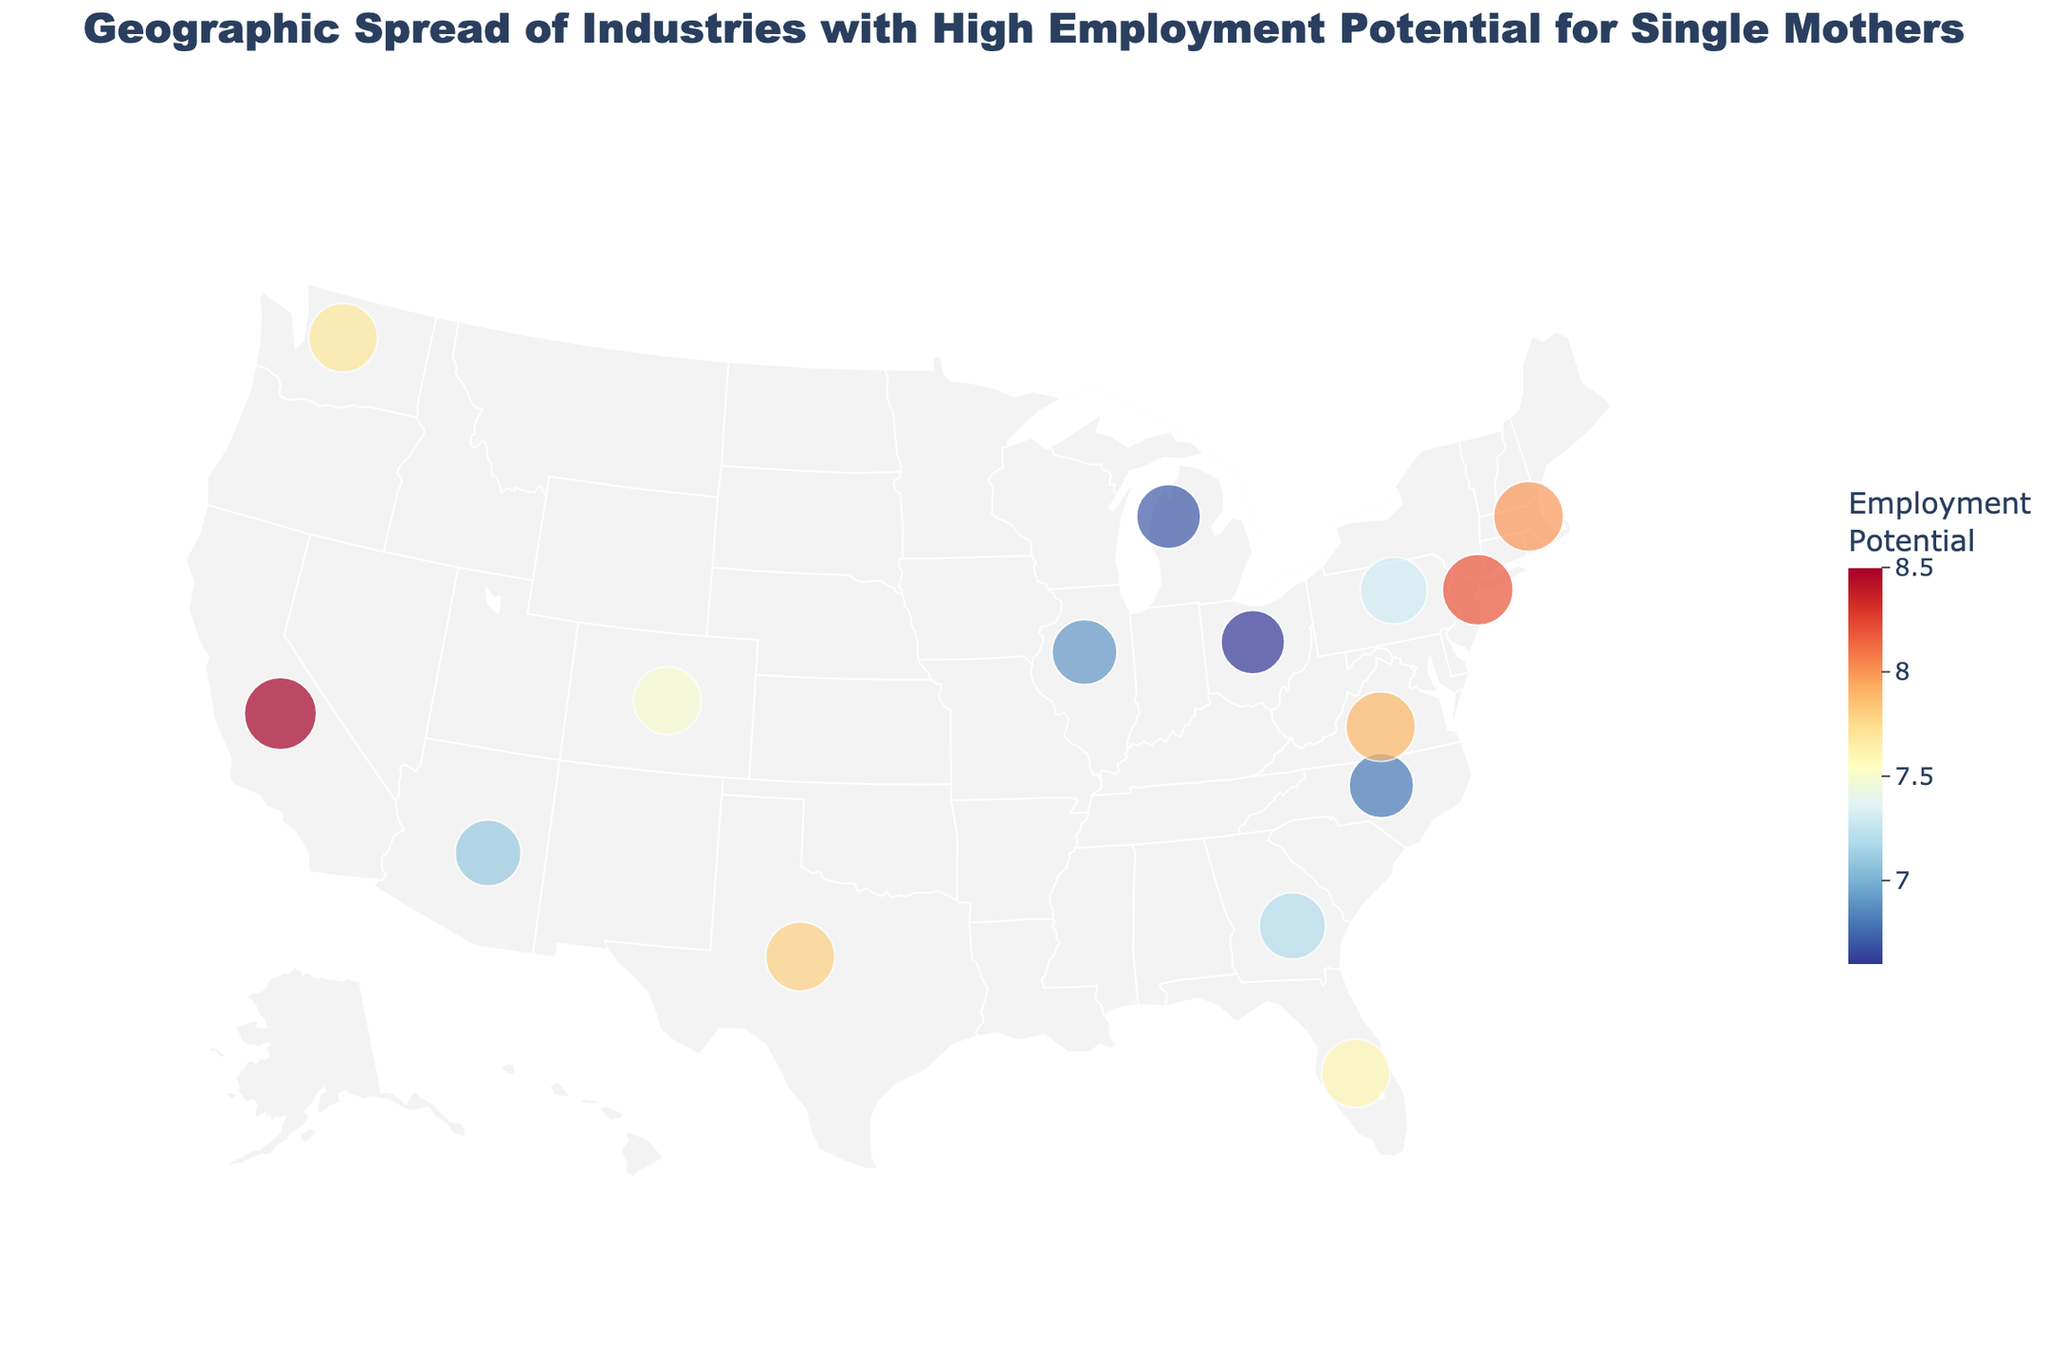What is the title of the figure? The title of the figure is typically located at the top and is often formatted in a larger font size. Here, it should be descriptive of the content, which is the Geographic Spread of Industries with High Employment Potential for Single Mothers.
Answer: Geographic Spread of Industries with High Employment Potential for Single Mothers Which state has the highest employment potential for single mothers? Look for the state with the highest number in the "Employment Potential" category on the map. The size of the marker and the color intensity can also indicate higher employment potential.
Answer: California What industry is represented in Florida? Hover over or find the text label near Florida on the map to identify the industry.
Answer: Hospitality How many states have an employment potential above 7.5? Count the number of data points (states) on the map where the "Employment Potential" is higher than 7.5, using the color gradient or size of the markers as a guide.
Answer: 7 Which industry has a high employment potential in Massachusetts? Find Massachusetts on the map and check the text label next to it or hover over its marker.
Answer: Biotechnology Compare the employment potential between Texas and Virginia. Which is higher? Locate Texas and Virginia on the map. Compare their "Employment Potential" values; Texas has Technology, and Virginia has Government Services.
Answer: Virginia What are the two states with the lowest employment potential, and what industries are they associated with? Identify the smallest markers or the ones with the least intense colors. Then, check the states and their associated industries from the text labels.
Answer: Ohio (Logistics) and Michigan (Automotive) Which industry is associated with an employment potential of 7.3? Look at the map for a marker with an employment potential value of 7.3. Hover over it or check its associated text label.
Answer: Insurance What is the color scale used in the map to represent employment potential? Examine the color gradient on the map; the color scale is crucial to interpreting the intensity of employment potential.
Answer: Red to Blue Which has a higher employment potential, E-commerce in Washington or Education in New York? Locate Washington and New York on the map, then compare their "Employment Potential" values listed beside E-commerce and Education respectively.
Answer: Education in New York 